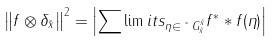Convert formula to latex. <formula><loc_0><loc_0><loc_500><loc_500>\left \| f \otimes \delta _ { \tilde { x } } \right \| ^ { 2 } = \left | \sum \lim i t s _ { \eta \in \tilde { \ } G _ { \tilde { x } } ^ { \tilde { x } } } f ^ { \ast } \ast f ( \eta ) \right |</formula> 